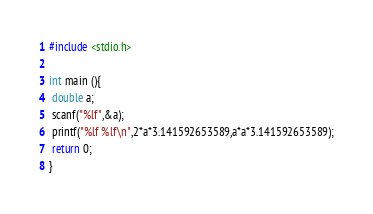Convert code to text. <code><loc_0><loc_0><loc_500><loc_500><_C_>#include <stdio.h>

int main (){
 double a;
 scanf("%lf",&a);
 printf("%lf %lf\n",2*a*3.141592653589,a*a*3.141592653589);
 return 0;
}</code> 